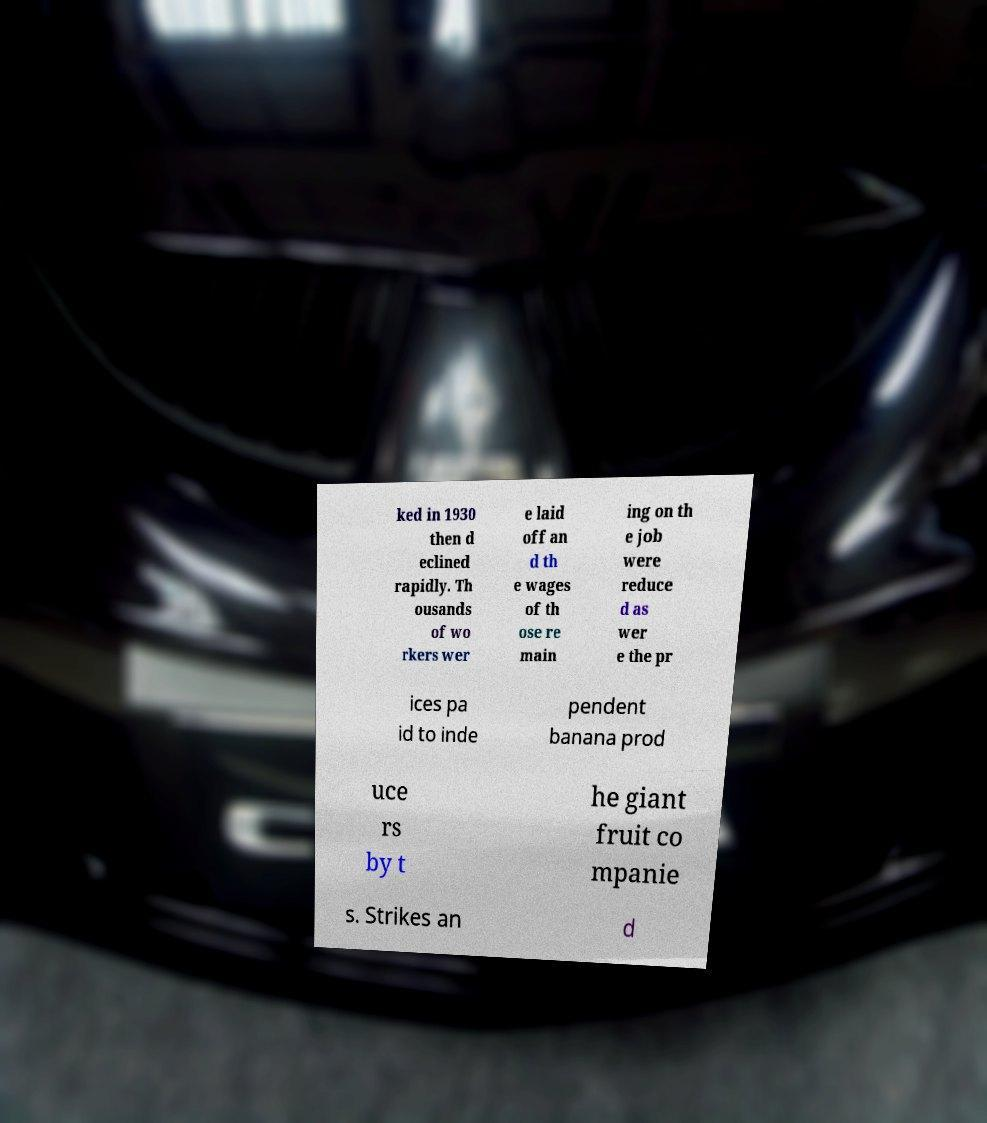I need the written content from this picture converted into text. Can you do that? ked in 1930 then d eclined rapidly. Th ousands of wo rkers wer e laid off an d th e wages of th ose re main ing on th e job were reduce d as wer e the pr ices pa id to inde pendent banana prod uce rs by t he giant fruit co mpanie s. Strikes an d 